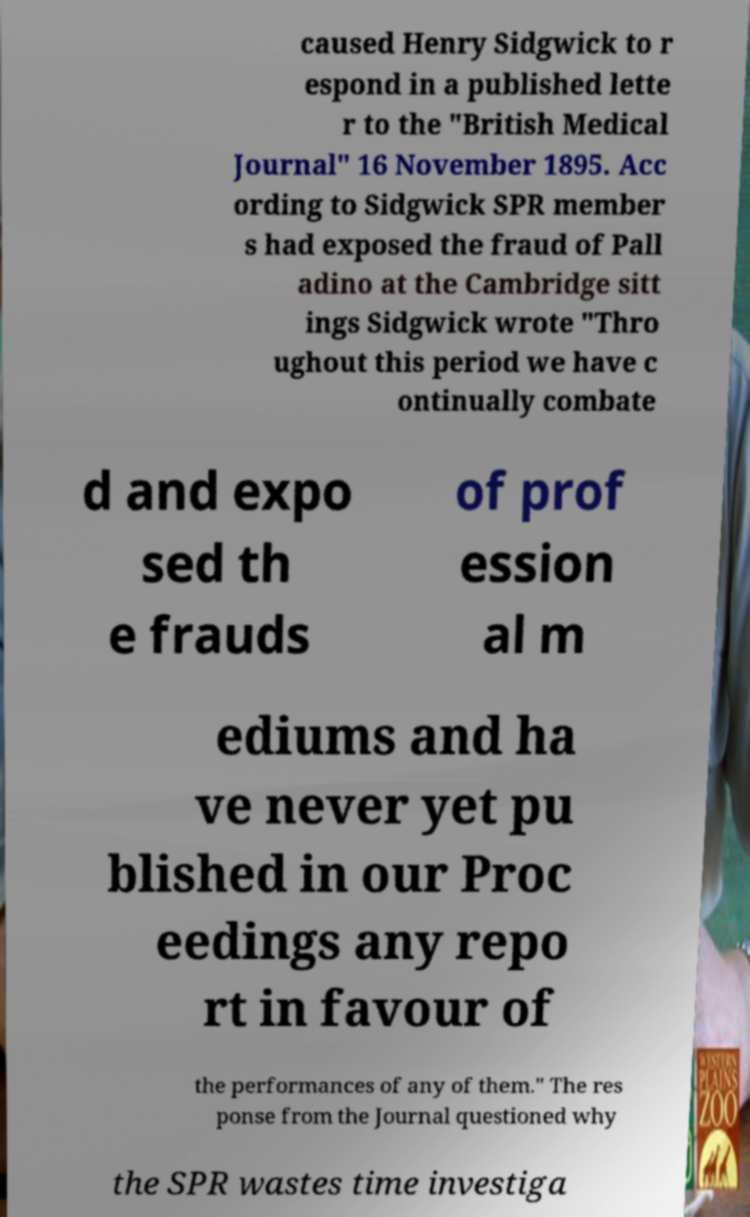Please identify and transcribe the text found in this image. caused Henry Sidgwick to r espond in a published lette r to the "British Medical Journal" 16 November 1895. Acc ording to Sidgwick SPR member s had exposed the fraud of Pall adino at the Cambridge sitt ings Sidgwick wrote "Thro ughout this period we have c ontinually combate d and expo sed th e frauds of prof ession al m ediums and ha ve never yet pu blished in our Proc eedings any repo rt in favour of the performances of any of them." The res ponse from the Journal questioned why the SPR wastes time investiga 